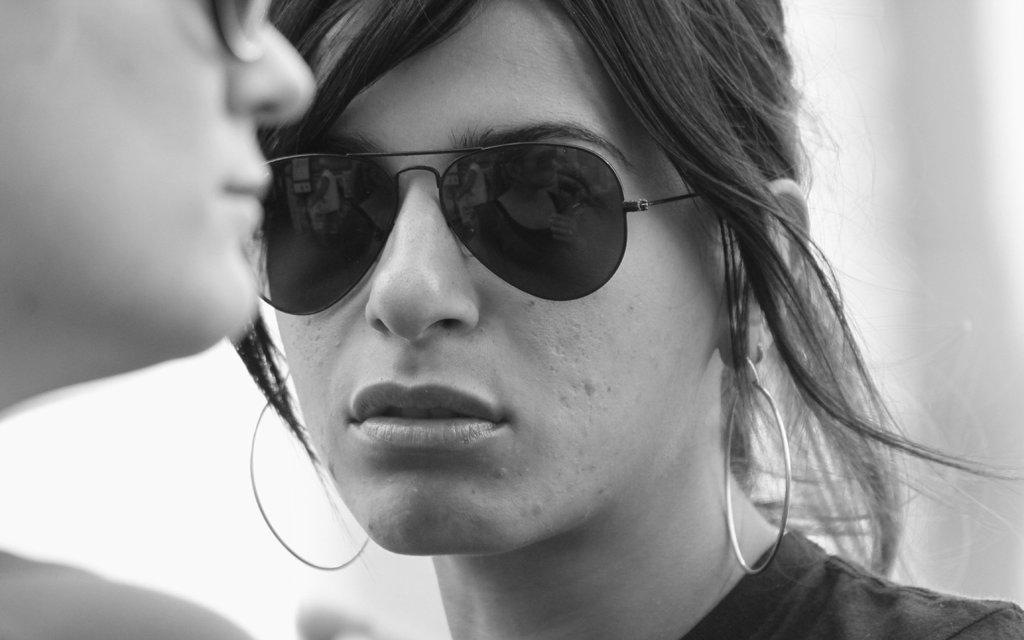Who is the main subject in the image? There is a woman in the image. What is the woman wearing on her face? The woman is wearing goggles. What type of accessory is the woman wearing? The woman is wearing earrings. Can you describe the person on the left side of the image? There is another person on the left side of the image. What is the background of the image like? The backdrop of the image is blurred. What type of haircut does the scarecrow have in the image? There is no scarecrow present in the image, so it is not possible to determine the type of haircut it might have. How many friends are visible in the image? The provided facts do not mention friends, so it is not possible to determine the number of friends visible in the image. 